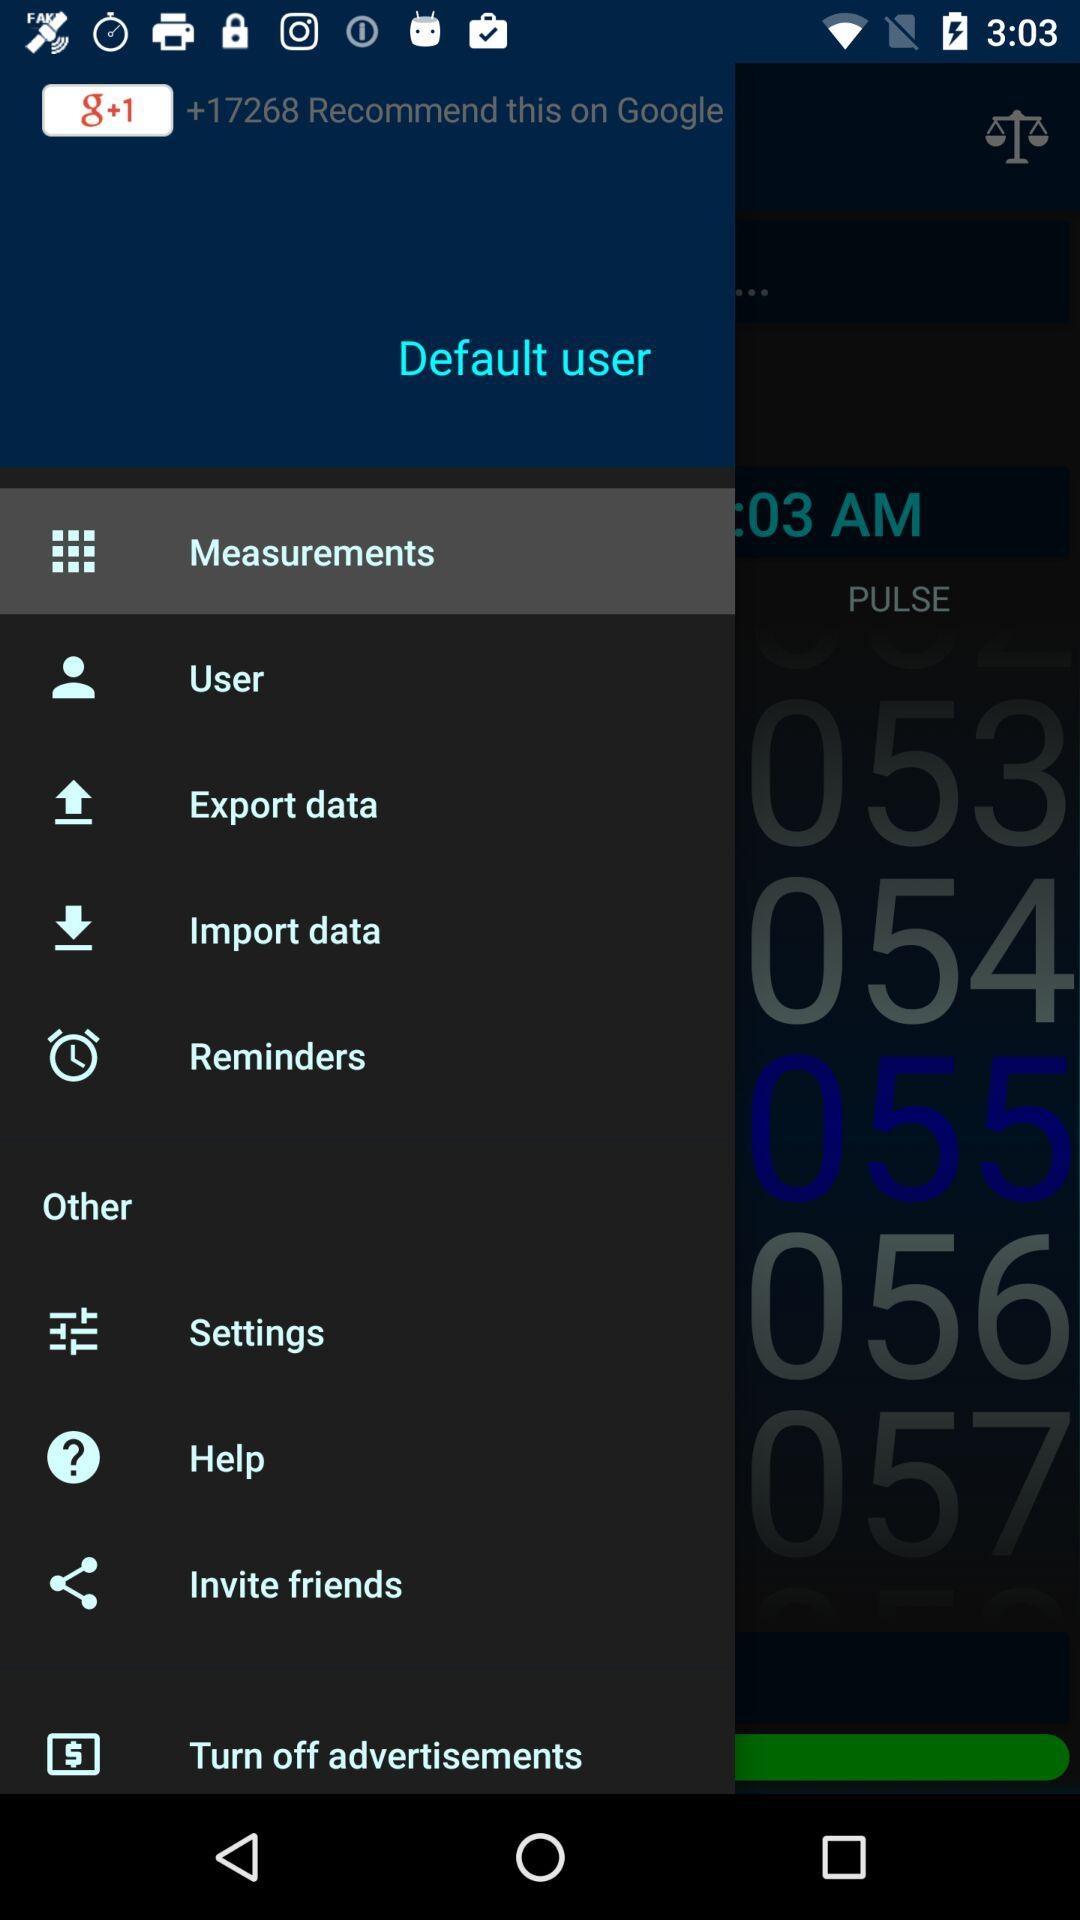Which option is selected? The selected option is "Measurements". 